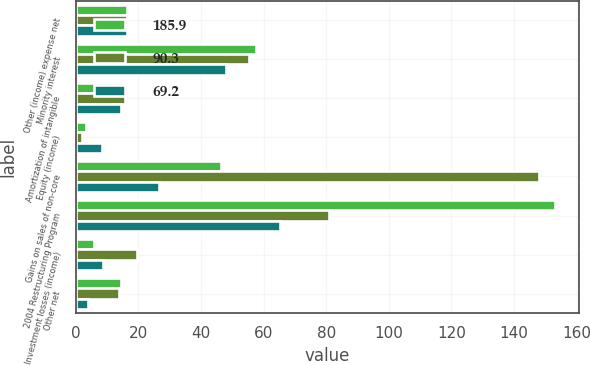<chart> <loc_0><loc_0><loc_500><loc_500><stacked_bar_chart><ecel><fcel>Other (income) expense net<fcel>Minority interest<fcel>Amortization of intangible<fcel>Equity (income)<fcel>Gains on sales of non-core<fcel>2004 Restructuring Program<fcel>Investment losses (income)<fcel>Other net<nl><fcel>185.9<fcel>16.3<fcel>57.5<fcel>16.3<fcel>3.4<fcel>46.5<fcel>153.1<fcel>5.7<fcel>14.6<nl><fcel>90.3<fcel>16.3<fcel>55.3<fcel>15.6<fcel>2<fcel>147.9<fcel>80.8<fcel>19.7<fcel>13.7<nl><fcel>69.2<fcel>16.3<fcel>47.9<fcel>14.3<fcel>8.5<fcel>26.7<fcel>65.3<fcel>8.7<fcel>3.9<nl></chart> 